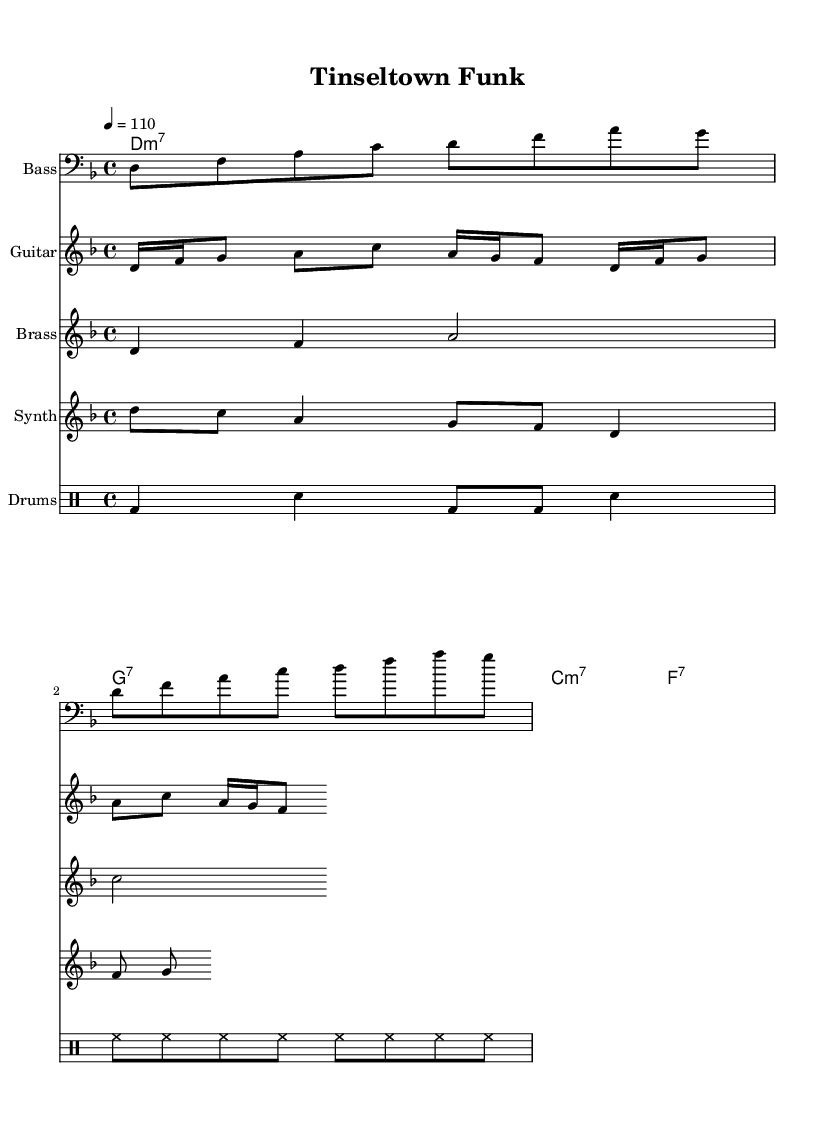What is the time signature of this music? The time signature is indicated at the beginning of the music, where it is written as "4/4," meaning there are four beats in each measure and the quarter note gets one beat.
Answer: 4/4 What is the key signature of this music? The key signature is shown at the beginning of the sheet music, which has a "d" indicated, suggesting it is in the key of D minor, which includes one flat (B flat).
Answer: D minor What is the tempo marking indicated in the score? The tempo is shown at the beginning of the score, with "4 = 110," indicating the speed, where the quarter note equals 110 beats per minute.
Answer: 110 How many measures are in the bass line? By counting the number of phrases in the bass line, there are two repeated sections, each containing two measures, totaling four measures.
Answer: 4 Which instrument plays the brass melody? The brass melody is designated for the brass instrument, as indicated by the staff labeled "Brass" in the rendered sheet music.
Answer: Brass What type of chords are used in the verse section? The verse contains a series of seventh chords, specifically "m7" and "7" chords, as shown in the chord names section above the bass line.
Answer: m7, 7 Which rhythmic pattern is played by the drums? The drum pattern is written in drummode, showing a combination of bass drum (bd), snare (sn), and hi-hat (hh) in a rhythmic sequence that repeats.
Answer: bd, sn, hh 